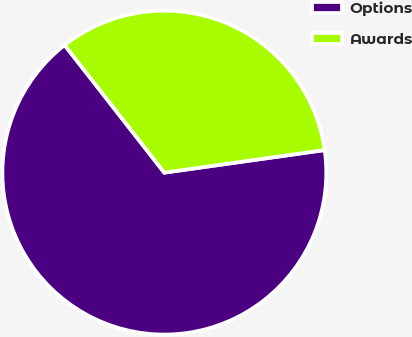Convert chart. <chart><loc_0><loc_0><loc_500><loc_500><pie_chart><fcel>Options<fcel>Awards<nl><fcel>66.67%<fcel>33.33%<nl></chart> 